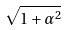<formula> <loc_0><loc_0><loc_500><loc_500>\sqrt { 1 + \alpha ^ { 2 } }</formula> 